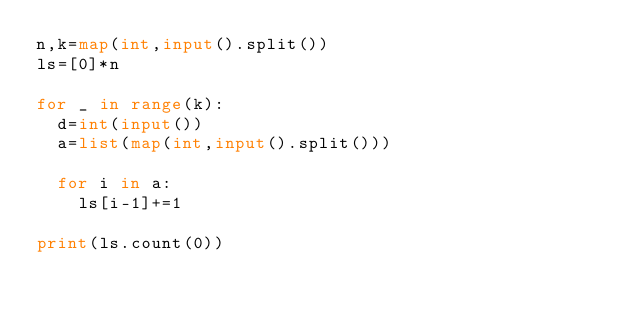<code> <loc_0><loc_0><loc_500><loc_500><_Python_>n,k=map(int,input().split())
ls=[0]*n

for _ in range(k):
  d=int(input())
  a=list(map(int,input().split()))
  
  for i in a:
    ls[i-1]+=1
    
print(ls.count(0))</code> 